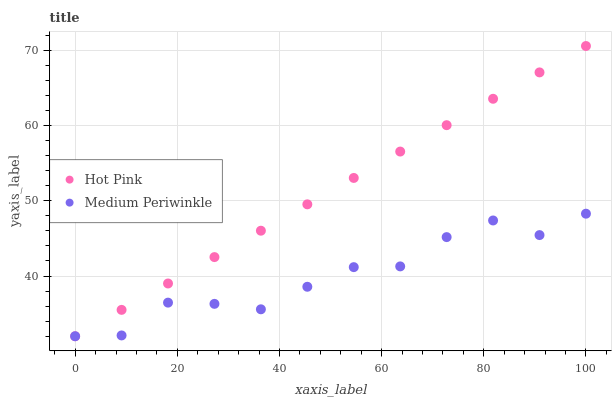Does Medium Periwinkle have the minimum area under the curve?
Answer yes or no. Yes. Does Hot Pink have the maximum area under the curve?
Answer yes or no. Yes. Does Medium Periwinkle have the maximum area under the curve?
Answer yes or no. No. Is Hot Pink the smoothest?
Answer yes or no. Yes. Is Medium Periwinkle the roughest?
Answer yes or no. Yes. Is Medium Periwinkle the smoothest?
Answer yes or no. No. Does Hot Pink have the lowest value?
Answer yes or no. Yes. Does Hot Pink have the highest value?
Answer yes or no. Yes. Does Medium Periwinkle have the highest value?
Answer yes or no. No. Does Hot Pink intersect Medium Periwinkle?
Answer yes or no. Yes. Is Hot Pink less than Medium Periwinkle?
Answer yes or no. No. Is Hot Pink greater than Medium Periwinkle?
Answer yes or no. No. 